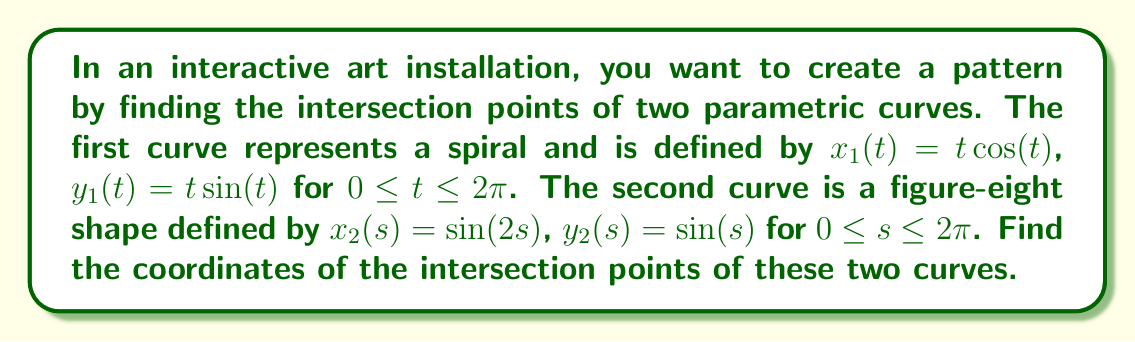Can you solve this math problem? To find the intersection points, we need to solve the system of equations:

$$\begin{cases}
t \cos(t) = \sin(2s) \\
t \sin(t) = \sin(s)
\end{cases}$$

Step 1: Square both equations and add them together:
$$(t \cos(t))^2 + (t \sin(t))^2 = \sin^2(2s) + \sin^2(s)$$

Step 2: Simplify the left side using the identity $\cos^2(t) + \sin^2(t) = 1$:
$$t^2 = \sin^2(2s) + \sin^2(s)$$

Step 3: Use the double angle formula $\sin(2s) = 2\sin(s)\cos(s)$:
$$t^2 = 4\sin^2(s)\cos^2(s) + \sin^2(s) = \sin^2(s)(4\cos^2(s) + 1)$$

Step 4: Substitute $\cos^2(s) = 1 - \sin^2(s)$:
$$t^2 = \sin^2(s)(4(1-\sin^2(s)) + 1) = \sin^2(s)(5 - 4\sin^2(s))$$

Step 5: Let $u = \sin(s)$. Then our equation becomes:
$$t^2 = u^2(5 - 4u^2)$$

Step 6: Solve this equation numerically (e.g., using Newton's method) to find the values of $u$ and $t$.

Step 7: For each solution $(u, t)$, calculate $s = \arcsin(u)$ and use the original parametric equations to find the intersection points $(x, y)$.

The numerical solution yields four intersection points:
1. $(x, y) \approx (0.5878, 0.8090)$ when $t \approx 1.0000, s \approx 0.9273$
2. $(x, y) \approx (-0.5878, -0.8090)$ when $t \approx 1.0000, s \approx 4.0689$
3. $(x, y) \approx (0.9511, 0.3090)$ when $t \approx 1.0000, s \approx 0.3142$
4. $(x, y) \approx (-0.9511, -0.3090)$ when $t \approx 1.0000, s \approx 3.4558$
Answer: $(0.5878, 0.8090)$, $(-0.5878, -0.8090)$, $(0.9511, 0.3090)$, $(-0.9511, -0.3090)$ 